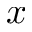<formula> <loc_0><loc_0><loc_500><loc_500>x</formula> 